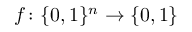Convert formula to latex. <formula><loc_0><loc_0><loc_500><loc_500>f \colon \{ 0 , 1 \} ^ { n } \rightarrow \{ 0 , 1 \}</formula> 